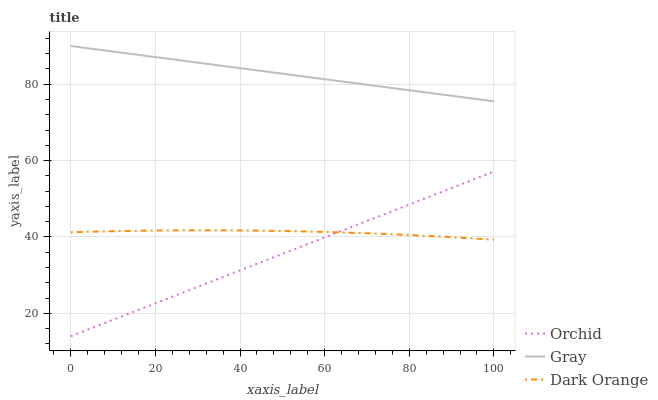Does Orchid have the minimum area under the curve?
Answer yes or no. Yes. Does Gray have the maximum area under the curve?
Answer yes or no. Yes. Does Gray have the minimum area under the curve?
Answer yes or no. No. Does Orchid have the maximum area under the curve?
Answer yes or no. No. Is Orchid the smoothest?
Answer yes or no. Yes. Is Dark Orange the roughest?
Answer yes or no. Yes. Is Gray the smoothest?
Answer yes or no. No. Is Gray the roughest?
Answer yes or no. No. Does Orchid have the lowest value?
Answer yes or no. Yes. Does Gray have the lowest value?
Answer yes or no. No. Does Gray have the highest value?
Answer yes or no. Yes. Does Orchid have the highest value?
Answer yes or no. No. Is Orchid less than Gray?
Answer yes or no. Yes. Is Gray greater than Orchid?
Answer yes or no. Yes. Does Orchid intersect Dark Orange?
Answer yes or no. Yes. Is Orchid less than Dark Orange?
Answer yes or no. No. Is Orchid greater than Dark Orange?
Answer yes or no. No. Does Orchid intersect Gray?
Answer yes or no. No. 